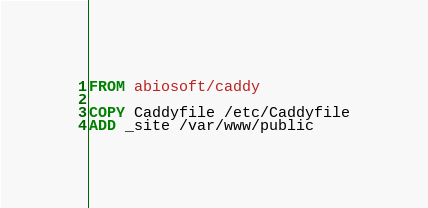Convert code to text. <code><loc_0><loc_0><loc_500><loc_500><_Dockerfile_>FROM abiosoft/caddy

COPY Caddyfile /etc/Caddyfile
ADD _site /var/www/public
</code> 